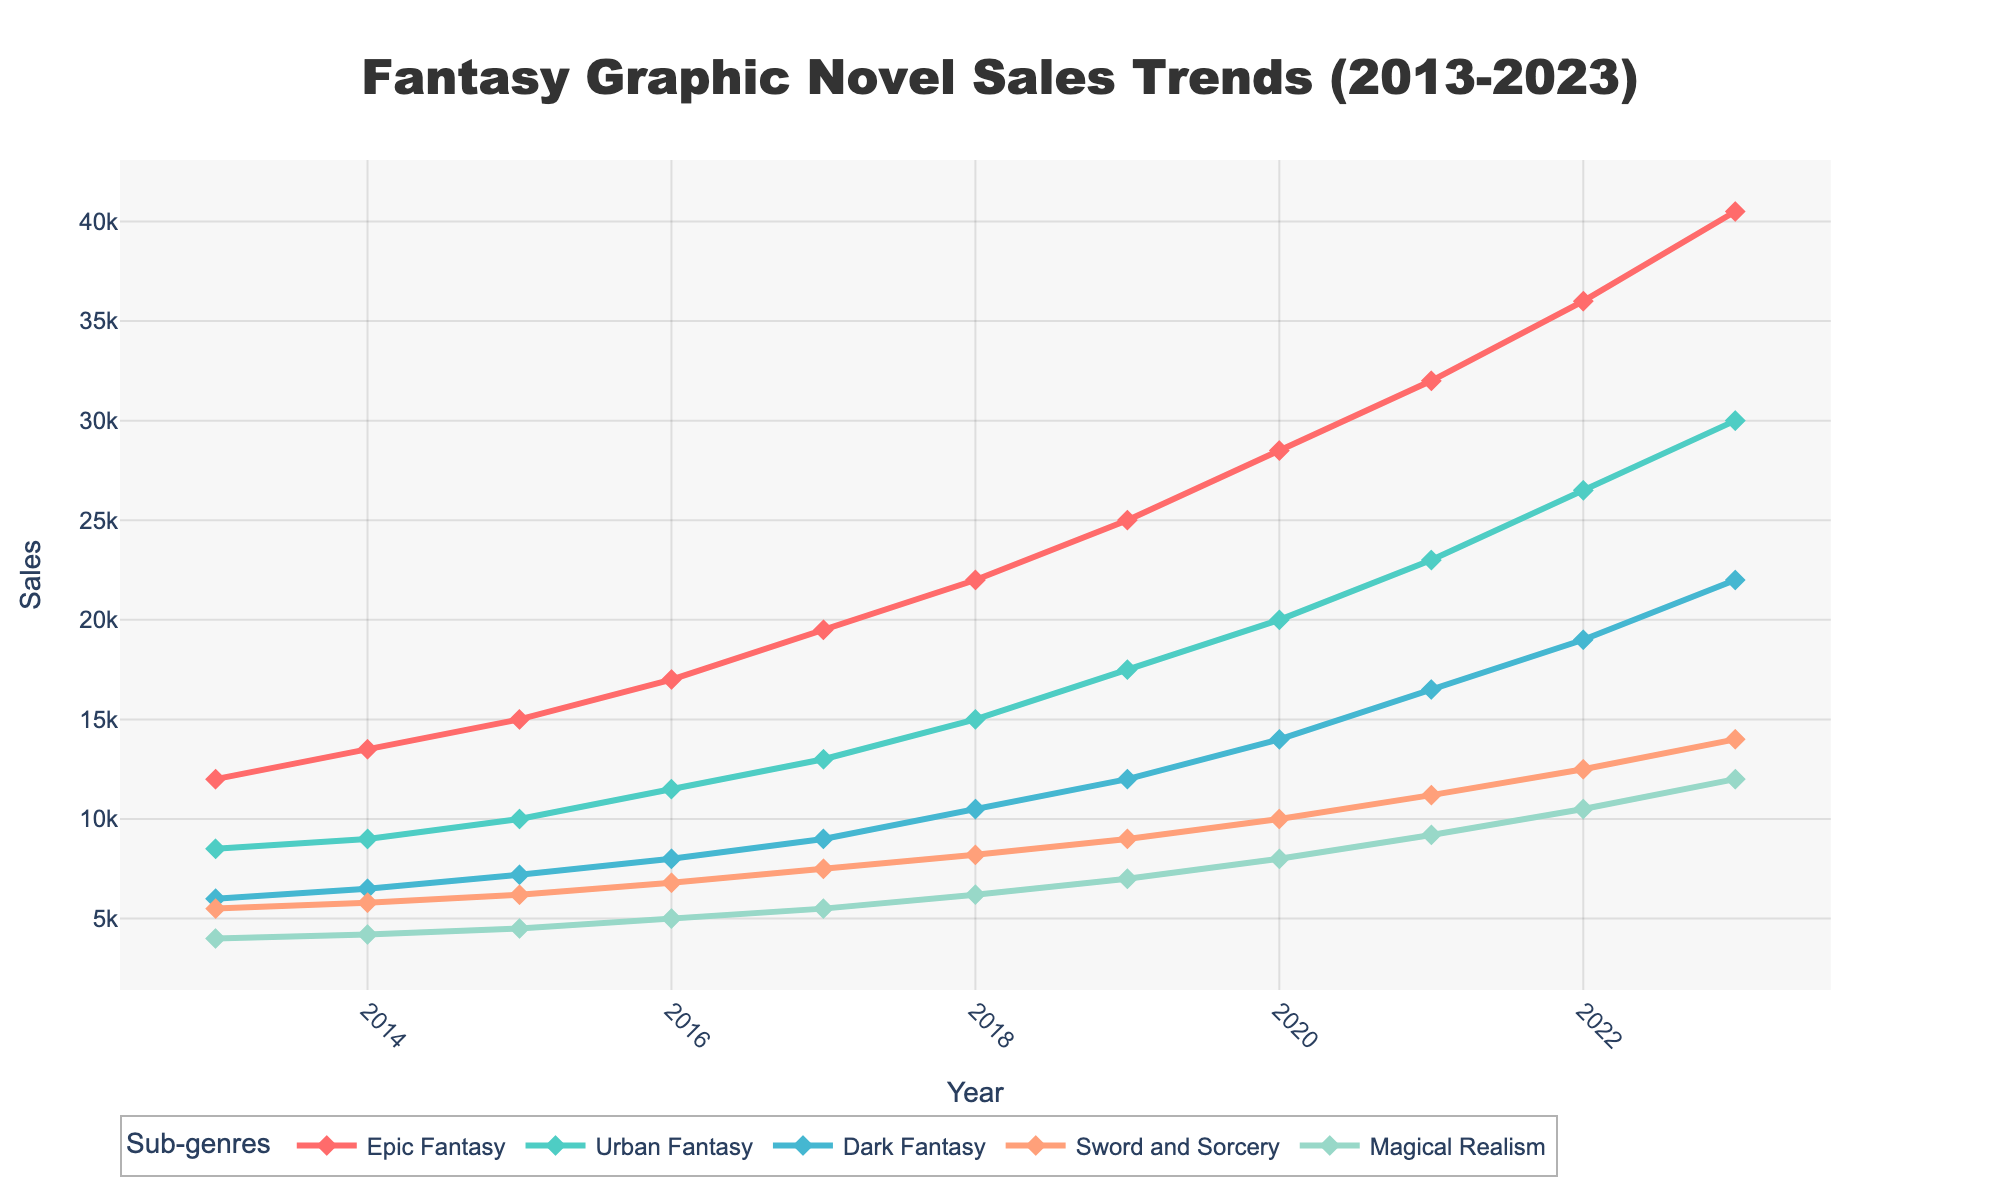What sub-genre had the highest sales in 2023? To find the highest sales in 2023, look at the 2023 data points on the chart. Compare the sales for each sub-genre.
Answer: Epic Fantasy Which sub-genre experienced the greatest increase in sales from 2013 to 2023? Calculate the difference in sales for each sub-genre between 2013 and 2023 and compare. Epic Fantasy increased from 12,000 to 40,500, Urban Fantasy from 8,500 to 30,000, Dark Fantasy from 6,000 to 22,000, Sword and Sorcery from 5,500 to 14,000, and Magical Realism from 4,000 to 12,000.
Answer: Epic Fantasy What was the average sales for Urban Fantasy between 2013 and 2023? Sum the sales figures for Urban Fantasy from 2013 to 2023 and divide by the number of years (11). (8500 + 9000 + 10000 + 11500 + 13000 + 15000 + 17500 + 20000 + 23000 + 26500 + 30000) / 11 = 17272.7273
Answer: 17,273 In what year did Dark Fantasy sales first surpass 10,000? Look at the Dark Fantasy sales line and find the first year where the sales exceed 10,000.
Answer: 2018 How does the sales growth trend of Sword and Sorcery compare to Magical Realism from 2013 to 2023? Compare the slopes of the growth lines for Sword and Sorcery and Magical Realism over the period. Both show growth, but Sword and Sorcery starts higher and maintains a steady increase, while Magical Realism starts lower and grows more slowly.
Answer: Sword and Sorcery grew more steadily and started higher What is the sum of sales for all sub-genres in 2020? Sum the sales figures for each sub-genre in 2020. 28,500 + 20,000 + 14,000 + 10,000 + 8,000 = 80,500
Answer: 80,500 Between 2017 and 2018, which sub-genre had the largest percentage increase in sales? Calculate the percentage increase for each sub-genre between 2017 and 2018 and compare. 
% Increase = (Sales in 2018 - Sales in 2017) / Sales in 2017 * 100. 
Epic Fantasy: (22000 - 19500) / 19500 * 100 = 12.82%
Urban Fantasy: (15000 - 13000) / 13000 * 100 = 15.38%
Dark Fantasy: (10500 - 9000) / 9000 * 100 = 16.67%
Sword and Sorcery: (8200 - 7500) / 7500 * 100 = 9.33%
Magical Realism: (6200 - 5500) / 5500 * 100 = 12.73%
Answer: Dark Fantasy Which sub-genre has a decreasing trend in values that might suggest it’s less popular over time? Observe the graph for any sub-genre with declining values. However, none of the sub-genres show a decreasing trend; all display an upward trajectory in sales from 2013 to 2023.
Answer: None 